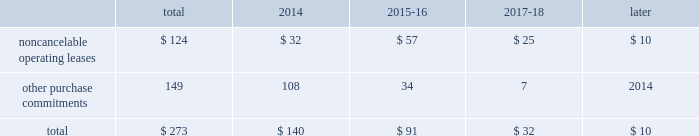23t .
Rowe price group | annual report 2013 contractual obligations the table presents a summary of our future obligations ( in millions ) under the terms of existing operating leases and other contractual cash purchase commitments at december 31 , 2013 .
Other purchase commitments include contractual amounts that will be due for the purchase of goods or services to be used in our operations and may be cancelable at earlier times than those indicated , under certain conditions that may involve termination fees .
Because these obligations are generally of a normal recurring nature , we expect that we will fund them from future cash flows from operations .
The information presented does not include operating expenses or capital expenditures that will be committed in the normal course of operations in 2014 and future years .
The information also excludes the $ 4.8 million of uncertain tax positions discussed in note 8 to our consolidated financial statements because it is not possible to estimate the time period in which a payment might be made to the tax authorities. .
We also have outstanding commitments to fund additional contributions to investment partnerships totaling $ 40.7 million at december 31 , 2013 .
The vast majority of these additional contributions will be made to investment partnerships in which we have an existing investment .
In addition to such amounts , a percentage of prior distributions may be called under certain circumstances .
In january 2014 , we renewed and extended our operating lease at our corporate headquarters in baltimore , maryland through 2027 .
This lease agreement increases the above disclosed total noncancelable operating lease commitments by an additional $ 133.0 million , the vast majority of which will be paid after 2018 .
Critical accounting policies the preparation of financial statements often requires the selection of specific accounting methods and policies from among several acceptable alternatives .
Further , significant estimates and judgments may be required in selecting and applying those methods and policies in the recognition of the assets and liabilities in our consolidated balance sheets , the revenues and expenses in our consolidated statements of income , and the information that is contained in our significant accounting policies and notes to consolidated financial statements .
Making these estimates and judgments requires the analysis of information concerning events that may not yet be complete and of facts and circumstances that may change over time .
Accordingly , actual amounts or future results can differ materially from those estimates that we include currently in our consolidated financial statements , significant accounting policies , and notes .
We present those significant accounting policies used in the preparation of our consolidated financial statements as an integral part of those statements within this 2013 annual report .
In the following discussion , we highlight and explain further certain of those policies that are most critical to the preparation and understanding of our financial statements .
Other-than-temporary impairments of available-for-sale securities .
We generally classify our investment holdings in sponsored funds as available-for-sale if we are not deemed to a have a controlling financial interest .
At the end of each quarter , we mark the carrying amount of each investment holding to fair value and recognize an unrealized gain or loss as a component of comprehensive income within the consolidated statements of comprehensive income .
We next review each individual security position that has an unrealized loss or impairment to determine if that impairment is other than temporary .
In determining whether a mutual fund holding is other-than-temporarily impaired , we consider many factors , including the duration of time it has existed , the severity of the impairment , any subsequent changes in value , and our intent and ability to hold the security for a period of time sufficient for an anticipated recovery in fair value .
Subject to the other considerations noted above , we believe a fund holding with an unrealized loss that has persisted daily throughout the six months between quarter-ends is generally presumed to have an other-than-temporary impairment .
We may also recognize an other-than-temporary loss of less than six months in our consolidated statements of income if the particular circumstances of the underlying investment do not warrant our belief that a near-term recovery is possible. .
As of december 31 , 2013 what percentage of total contractual obligations is due to noncancelable operating leases? 
Computations: (124 / 273)
Answer: 0.45421. 